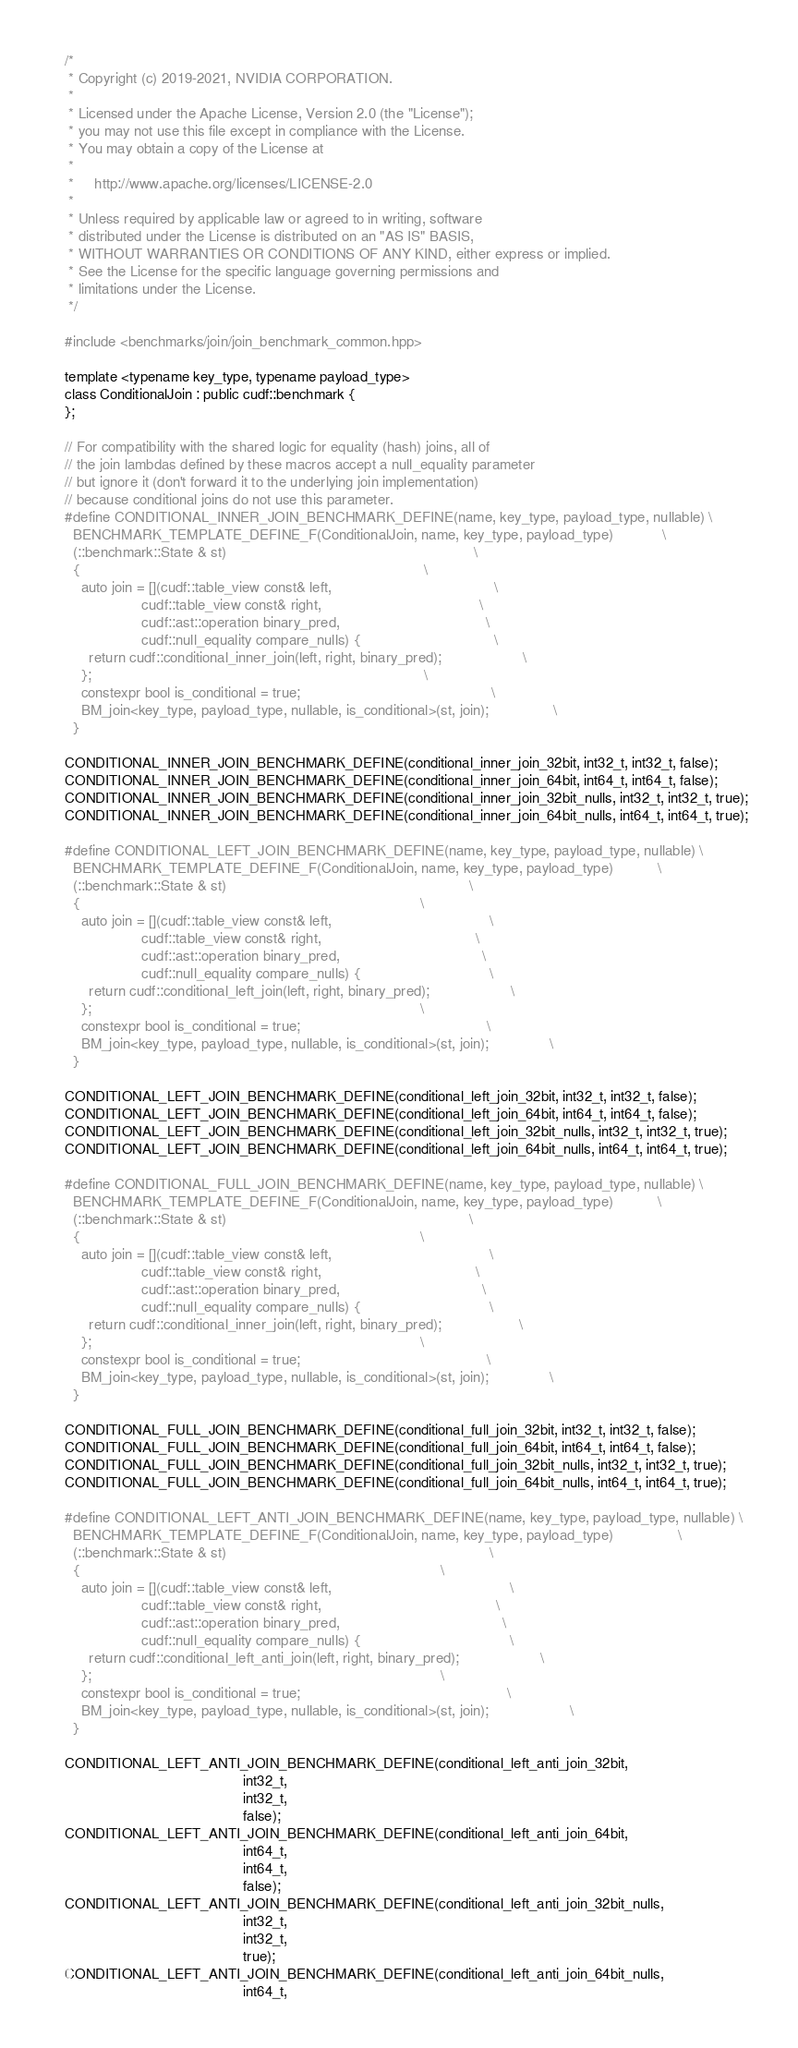Convert code to text. <code><loc_0><loc_0><loc_500><loc_500><_Cuda_>/*
 * Copyright (c) 2019-2021, NVIDIA CORPORATION.
 *
 * Licensed under the Apache License, Version 2.0 (the "License");
 * you may not use this file except in compliance with the License.
 * You may obtain a copy of the License at
 *
 *     http://www.apache.org/licenses/LICENSE-2.0
 *
 * Unless required by applicable law or agreed to in writing, software
 * distributed under the License is distributed on an "AS IS" BASIS,
 * WITHOUT WARRANTIES OR CONDITIONS OF ANY KIND, either express or implied.
 * See the License for the specific language governing permissions and
 * limitations under the License.
 */

#include <benchmarks/join/join_benchmark_common.hpp>

template <typename key_type, typename payload_type>
class ConditionalJoin : public cudf::benchmark {
};

// For compatibility with the shared logic for equality (hash) joins, all of
// the join lambdas defined by these macros accept a null_equality parameter
// but ignore it (don't forward it to the underlying join implementation)
// because conditional joins do not use this parameter.
#define CONDITIONAL_INNER_JOIN_BENCHMARK_DEFINE(name, key_type, payload_type, nullable) \
  BENCHMARK_TEMPLATE_DEFINE_F(ConditionalJoin, name, key_type, payload_type)            \
  (::benchmark::State & st)                                                             \
  {                                                                                     \
    auto join = [](cudf::table_view const& left,                                        \
                   cudf::table_view const& right,                                       \
                   cudf::ast::operation binary_pred,                                    \
                   cudf::null_equality compare_nulls) {                                 \
      return cudf::conditional_inner_join(left, right, binary_pred);                    \
    };                                                                                  \
    constexpr bool is_conditional = true;                                               \
    BM_join<key_type, payload_type, nullable, is_conditional>(st, join);                \
  }

CONDITIONAL_INNER_JOIN_BENCHMARK_DEFINE(conditional_inner_join_32bit, int32_t, int32_t, false);
CONDITIONAL_INNER_JOIN_BENCHMARK_DEFINE(conditional_inner_join_64bit, int64_t, int64_t, false);
CONDITIONAL_INNER_JOIN_BENCHMARK_DEFINE(conditional_inner_join_32bit_nulls, int32_t, int32_t, true);
CONDITIONAL_INNER_JOIN_BENCHMARK_DEFINE(conditional_inner_join_64bit_nulls, int64_t, int64_t, true);

#define CONDITIONAL_LEFT_JOIN_BENCHMARK_DEFINE(name, key_type, payload_type, nullable) \
  BENCHMARK_TEMPLATE_DEFINE_F(ConditionalJoin, name, key_type, payload_type)           \
  (::benchmark::State & st)                                                            \
  {                                                                                    \
    auto join = [](cudf::table_view const& left,                                       \
                   cudf::table_view const& right,                                      \
                   cudf::ast::operation binary_pred,                                   \
                   cudf::null_equality compare_nulls) {                                \
      return cudf::conditional_left_join(left, right, binary_pred);                    \
    };                                                                                 \
    constexpr bool is_conditional = true;                                              \
    BM_join<key_type, payload_type, nullable, is_conditional>(st, join);               \
  }

CONDITIONAL_LEFT_JOIN_BENCHMARK_DEFINE(conditional_left_join_32bit, int32_t, int32_t, false);
CONDITIONAL_LEFT_JOIN_BENCHMARK_DEFINE(conditional_left_join_64bit, int64_t, int64_t, false);
CONDITIONAL_LEFT_JOIN_BENCHMARK_DEFINE(conditional_left_join_32bit_nulls, int32_t, int32_t, true);
CONDITIONAL_LEFT_JOIN_BENCHMARK_DEFINE(conditional_left_join_64bit_nulls, int64_t, int64_t, true);

#define CONDITIONAL_FULL_JOIN_BENCHMARK_DEFINE(name, key_type, payload_type, nullable) \
  BENCHMARK_TEMPLATE_DEFINE_F(ConditionalJoin, name, key_type, payload_type)           \
  (::benchmark::State & st)                                                            \
  {                                                                                    \
    auto join = [](cudf::table_view const& left,                                       \
                   cudf::table_view const& right,                                      \
                   cudf::ast::operation binary_pred,                                   \
                   cudf::null_equality compare_nulls) {                                \
      return cudf::conditional_inner_join(left, right, binary_pred);                   \
    };                                                                                 \
    constexpr bool is_conditional = true;                                              \
    BM_join<key_type, payload_type, nullable, is_conditional>(st, join);               \
  }

CONDITIONAL_FULL_JOIN_BENCHMARK_DEFINE(conditional_full_join_32bit, int32_t, int32_t, false);
CONDITIONAL_FULL_JOIN_BENCHMARK_DEFINE(conditional_full_join_64bit, int64_t, int64_t, false);
CONDITIONAL_FULL_JOIN_BENCHMARK_DEFINE(conditional_full_join_32bit_nulls, int32_t, int32_t, true);
CONDITIONAL_FULL_JOIN_BENCHMARK_DEFINE(conditional_full_join_64bit_nulls, int64_t, int64_t, true);

#define CONDITIONAL_LEFT_ANTI_JOIN_BENCHMARK_DEFINE(name, key_type, payload_type, nullable) \
  BENCHMARK_TEMPLATE_DEFINE_F(ConditionalJoin, name, key_type, payload_type)                \
  (::benchmark::State & st)                                                                 \
  {                                                                                         \
    auto join = [](cudf::table_view const& left,                                            \
                   cudf::table_view const& right,                                           \
                   cudf::ast::operation binary_pred,                                        \
                   cudf::null_equality compare_nulls) {                                     \
      return cudf::conditional_left_anti_join(left, right, binary_pred);                    \
    };                                                                                      \
    constexpr bool is_conditional = true;                                                   \
    BM_join<key_type, payload_type, nullable, is_conditional>(st, join);                    \
  }

CONDITIONAL_LEFT_ANTI_JOIN_BENCHMARK_DEFINE(conditional_left_anti_join_32bit,
                                            int32_t,
                                            int32_t,
                                            false);
CONDITIONAL_LEFT_ANTI_JOIN_BENCHMARK_DEFINE(conditional_left_anti_join_64bit,
                                            int64_t,
                                            int64_t,
                                            false);
CONDITIONAL_LEFT_ANTI_JOIN_BENCHMARK_DEFINE(conditional_left_anti_join_32bit_nulls,
                                            int32_t,
                                            int32_t,
                                            true);
CONDITIONAL_LEFT_ANTI_JOIN_BENCHMARK_DEFINE(conditional_left_anti_join_64bit_nulls,
                                            int64_t,</code> 